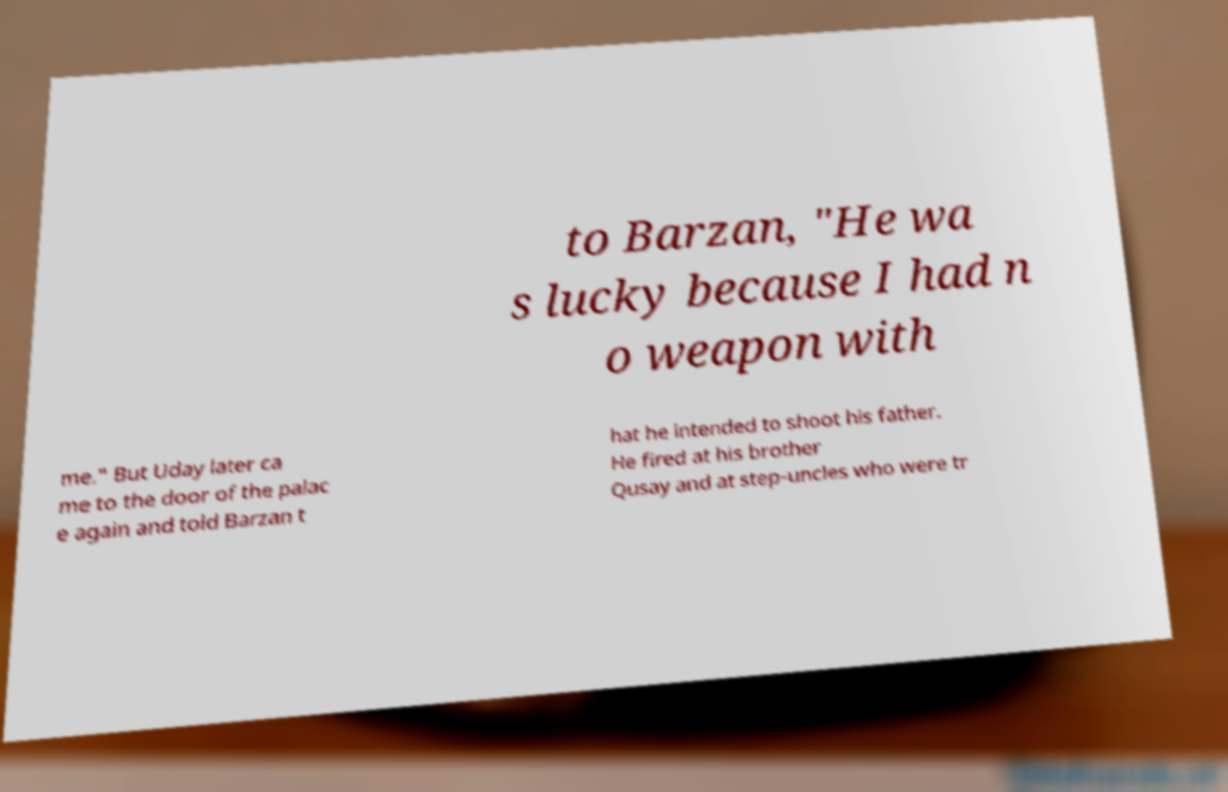For documentation purposes, I need the text within this image transcribed. Could you provide that? to Barzan, "He wa s lucky because I had n o weapon with me." But Uday later ca me to the door of the palac e again and told Barzan t hat he intended to shoot his father. He fired at his brother Qusay and at step-uncles who were tr 